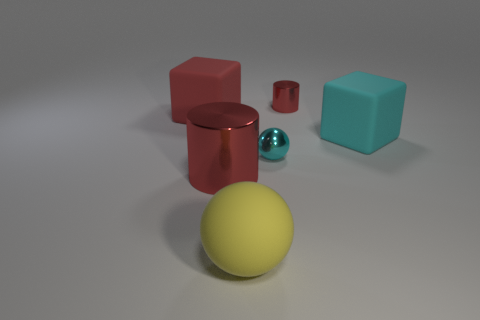Add 2 large purple metallic blocks. How many objects exist? 8 Subtract all big red objects. Subtract all matte cubes. How many objects are left? 2 Add 5 cyan matte things. How many cyan matte things are left? 6 Add 4 gray blocks. How many gray blocks exist? 4 Subtract 0 cyan cylinders. How many objects are left? 6 Subtract all balls. How many objects are left? 4 